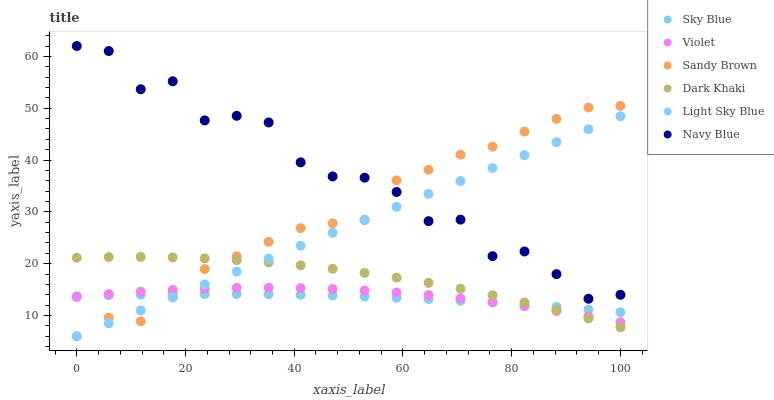Does Sky Blue have the minimum area under the curve?
Answer yes or no. Yes. Does Navy Blue have the maximum area under the curve?
Answer yes or no. Yes. Does Dark Khaki have the minimum area under the curve?
Answer yes or no. No. Does Dark Khaki have the maximum area under the curve?
Answer yes or no. No. Is Light Sky Blue the smoothest?
Answer yes or no. Yes. Is Navy Blue the roughest?
Answer yes or no. Yes. Is Dark Khaki the smoothest?
Answer yes or no. No. Is Dark Khaki the roughest?
Answer yes or no. No. Does Light Sky Blue have the lowest value?
Answer yes or no. Yes. Does Dark Khaki have the lowest value?
Answer yes or no. No. Does Navy Blue have the highest value?
Answer yes or no. Yes. Does Dark Khaki have the highest value?
Answer yes or no. No. Is Sky Blue less than Navy Blue?
Answer yes or no. Yes. Is Navy Blue greater than Sky Blue?
Answer yes or no. Yes. Does Light Sky Blue intersect Dark Khaki?
Answer yes or no. Yes. Is Light Sky Blue less than Dark Khaki?
Answer yes or no. No. Is Light Sky Blue greater than Dark Khaki?
Answer yes or no. No. Does Sky Blue intersect Navy Blue?
Answer yes or no. No. 